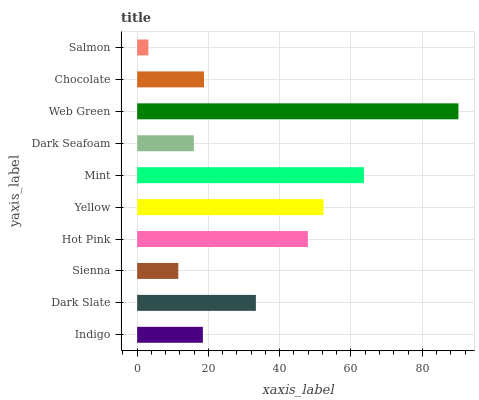Is Salmon the minimum?
Answer yes or no. Yes. Is Web Green the maximum?
Answer yes or no. Yes. Is Dark Slate the minimum?
Answer yes or no. No. Is Dark Slate the maximum?
Answer yes or no. No. Is Dark Slate greater than Indigo?
Answer yes or no. Yes. Is Indigo less than Dark Slate?
Answer yes or no. Yes. Is Indigo greater than Dark Slate?
Answer yes or no. No. Is Dark Slate less than Indigo?
Answer yes or no. No. Is Dark Slate the high median?
Answer yes or no. Yes. Is Chocolate the low median?
Answer yes or no. Yes. Is Chocolate the high median?
Answer yes or no. No. Is Yellow the low median?
Answer yes or no. No. 